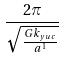Convert formula to latex. <formula><loc_0><loc_0><loc_500><loc_500>\frac { 2 \pi } { \sqrt { \frac { G k _ { y u c } } { a ^ { 1 } } } }</formula> 